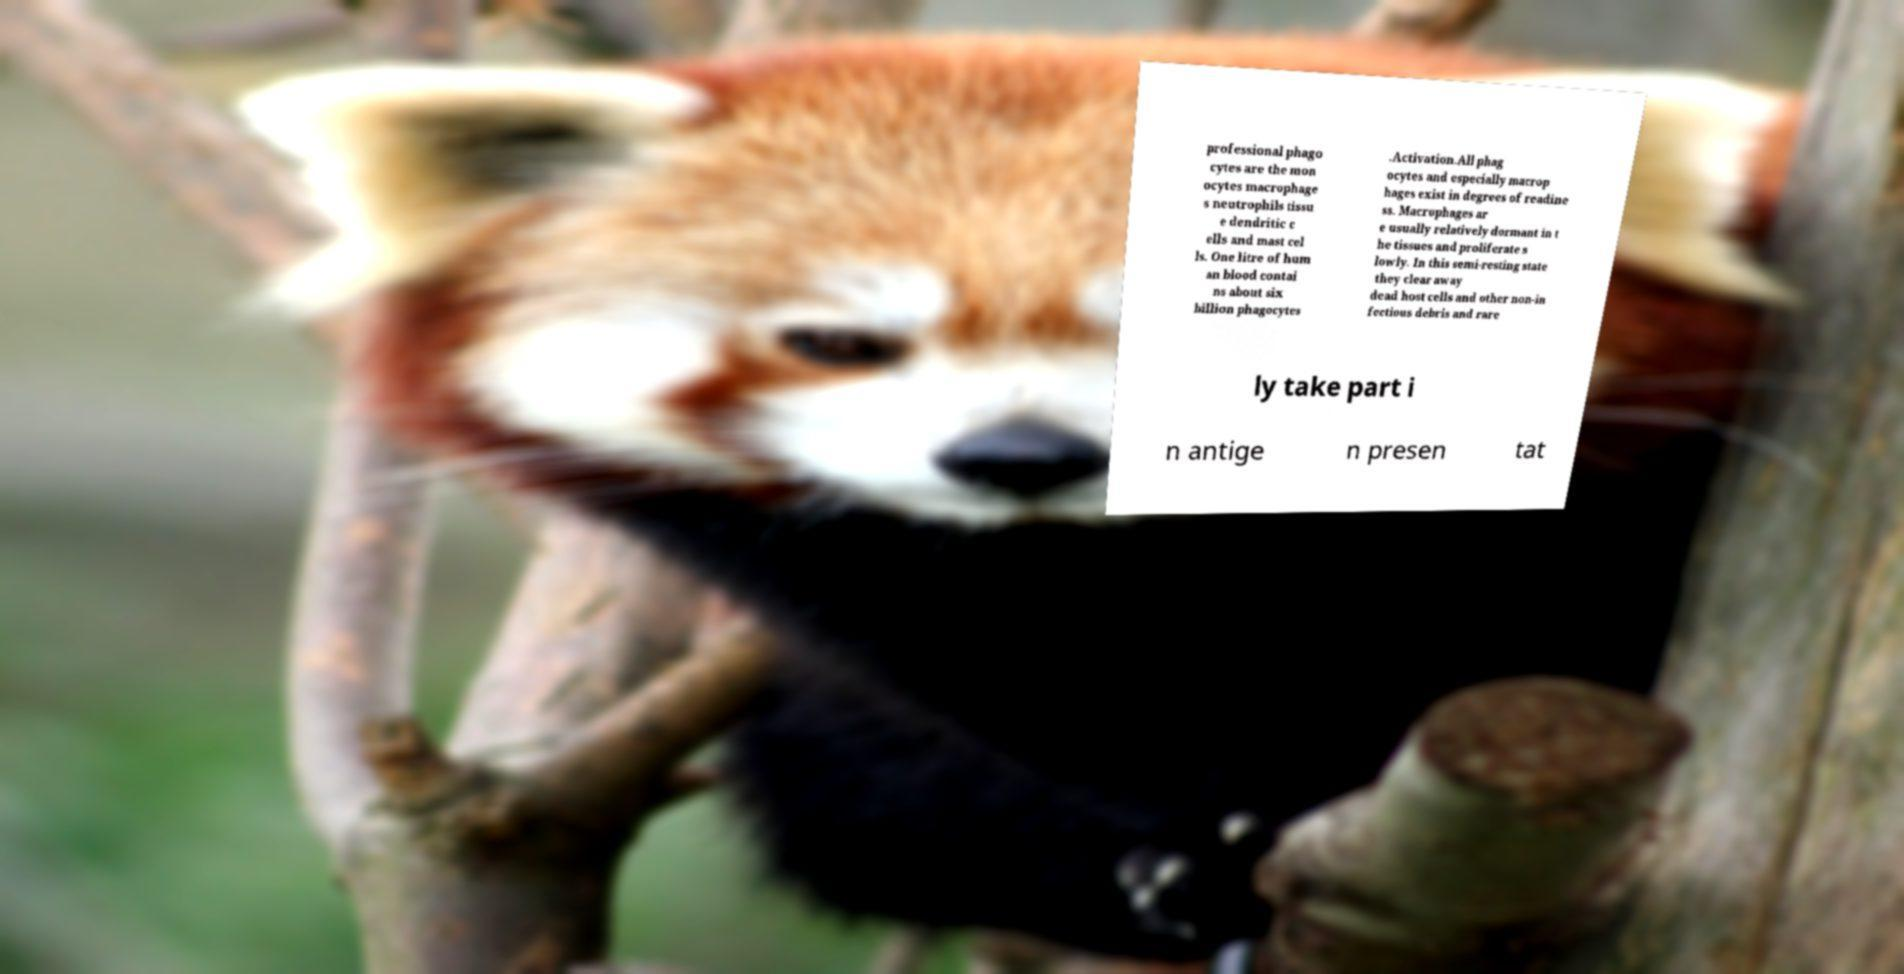Can you accurately transcribe the text from the provided image for me? professional phago cytes are the mon ocytes macrophage s neutrophils tissu e dendritic c ells and mast cel ls. One litre of hum an blood contai ns about six billion phagocytes .Activation.All phag ocytes and especially macrop hages exist in degrees of readine ss. Macrophages ar e usually relatively dormant in t he tissues and proliferate s lowly. In this semi-resting state they clear away dead host cells and other non-in fectious debris and rare ly take part i n antige n presen tat 